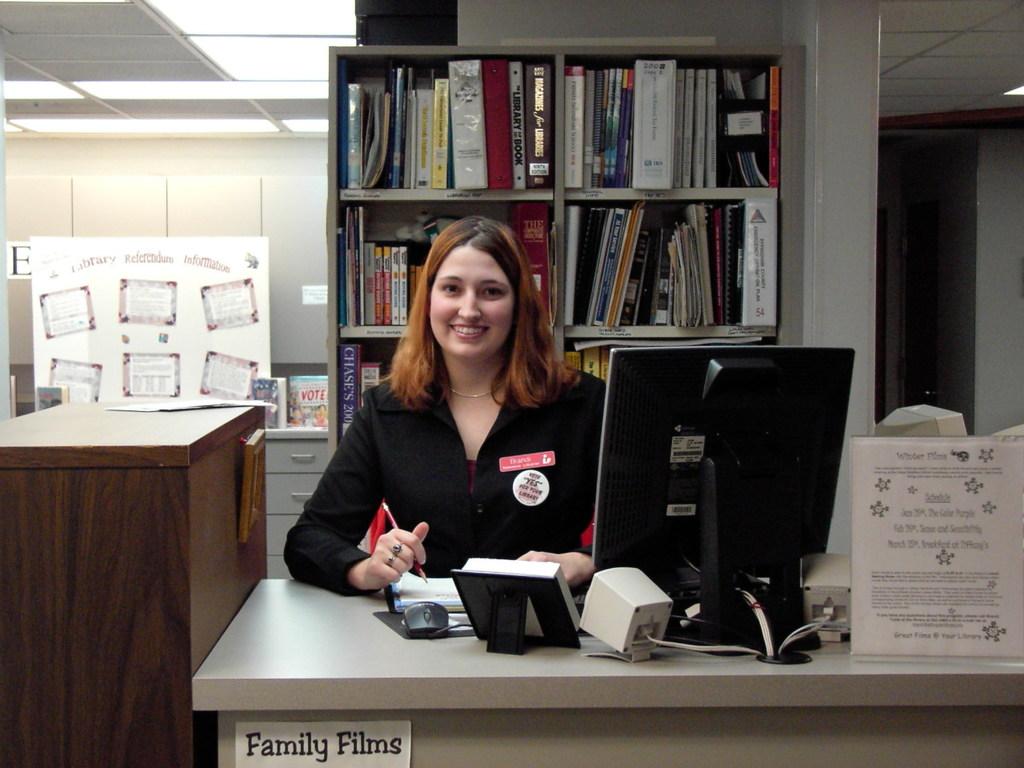What kind of films?
Make the answer very short. Family. What is the letter shown on the far left in the background?
Your answer should be compact. E. 